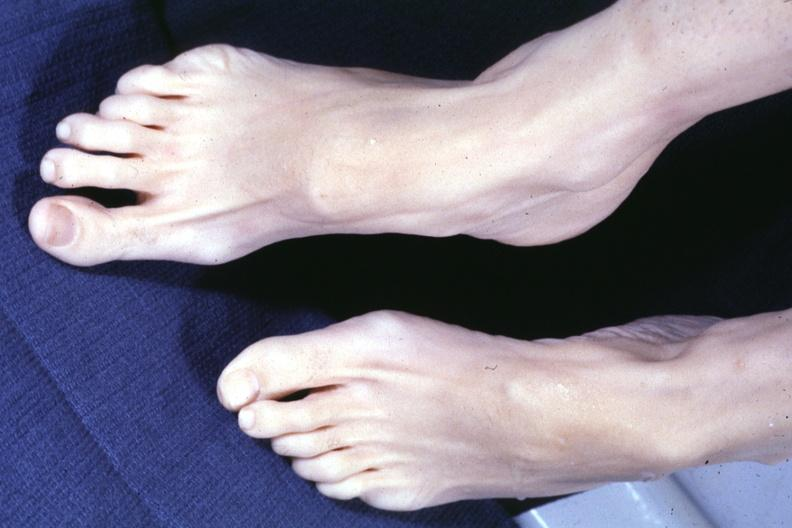s hours present?
Answer the question using a single word or phrase. No 